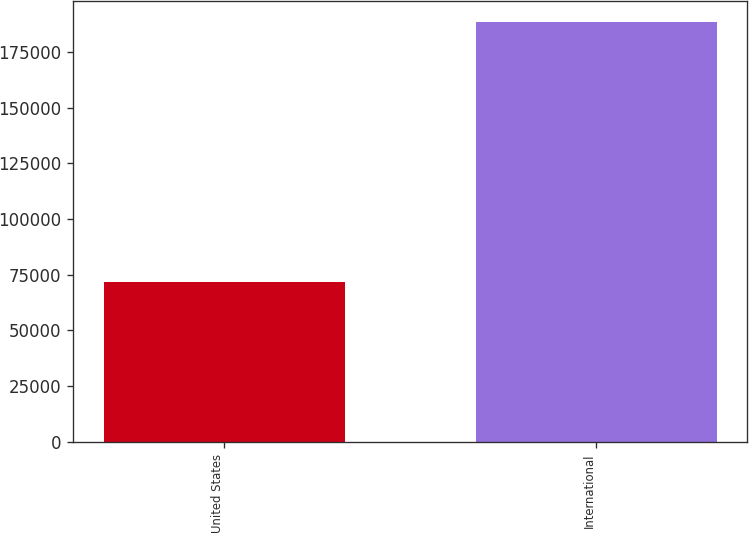Convert chart. <chart><loc_0><loc_0><loc_500><loc_500><bar_chart><fcel>United States<fcel>International<nl><fcel>71759<fcel>188329<nl></chart> 